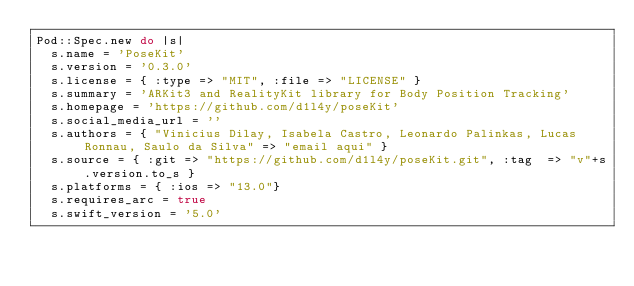Convert code to text. <code><loc_0><loc_0><loc_500><loc_500><_Ruby_>Pod::Spec.new do |s|
  s.name = 'PoseKit'
  s.version = '0.3.0'
  s.license = { :type => "MIT", :file => "LICENSE" }
  s.summary = 'ARKit3 and RealityKit library for Body Position Tracking'
  s.homepage = 'https://github.com/d1l4y/poseKit'
  s.social_media_url = ''
  s.authors = { "Vinicius Dilay, Isabela Castro, Leonardo Palinkas, Lucas Ronnau, Saulo da Silva" => "email aqui" }
  s.source = { :git => "https://github.com/d1l4y/poseKit.git", :tag  => "v"+s.version.to_s }
  s.platforms = { :ios => "13.0"}
  s.requires_arc = true
  s.swift_version = '5.0'</code> 